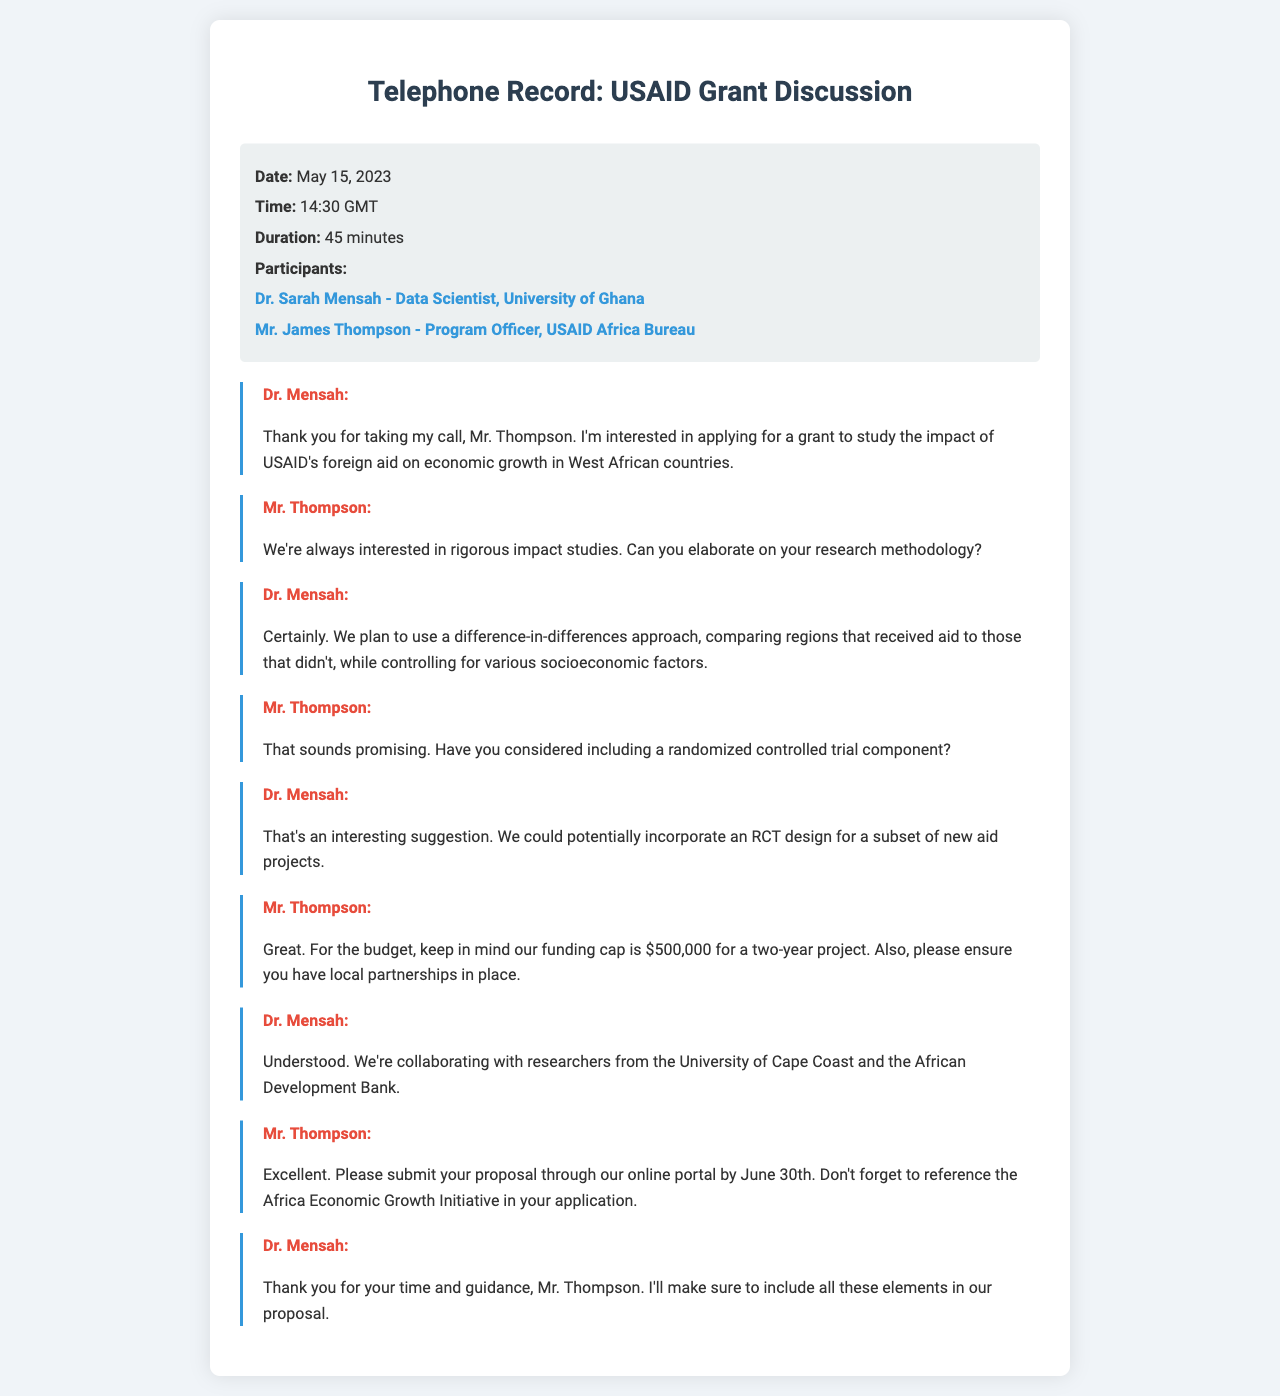what is the date of the call? The date of the call is mentioned in the call details section of the document.
Answer: May 15, 2023 who is Dr. Mensah? Dr. Mensah is identified as a data scientist from the University of Ghana in the participants section.
Answer: Data Scientist, University of Ghana what research methodology does Dr. Mensah plan to use? Dr. Mensah describes her research methodology in her conversation, highlighting a specific approach.
Answer: Difference-in-differences what is the funding cap for the project? Mr. Thompson mentions the funding cap during the discussion about the budget.
Answer: $500,000 when should the proposal be submitted? The submission deadline is explicitly stated in the call transcript by Mr. Thompson.
Answer: June 30th what organizations is Dr. Mensah collaborating with? Dr. Mensah lists her collaborators during the conversation with Mr. Thompson.
Answer: University of Cape Coast and the African Development Bank what is the duration of the grant project? The duration of the project is provided in the context of the funding cap discussed.
Answer: Two years what is the primary focus of Dr. Mensah's grant application? Dr. Mensah indicates the main area of her research when she initiates the call.
Answer: Impact of USAID's foreign aid on economic growth what component did Mr. Thompson suggest including in the study? Mr. Thompson provides a suggestion regarding the research design during the conversation.
Answer: Randomized controlled trial 